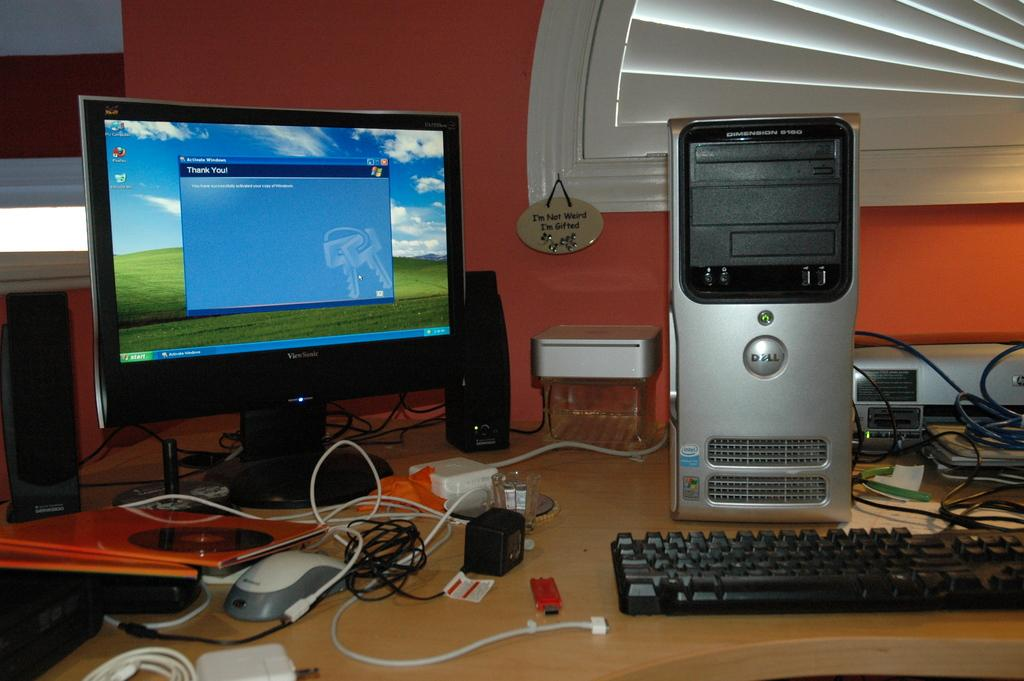<image>
Relay a brief, clear account of the picture shown. the words thank you that are on the screen 